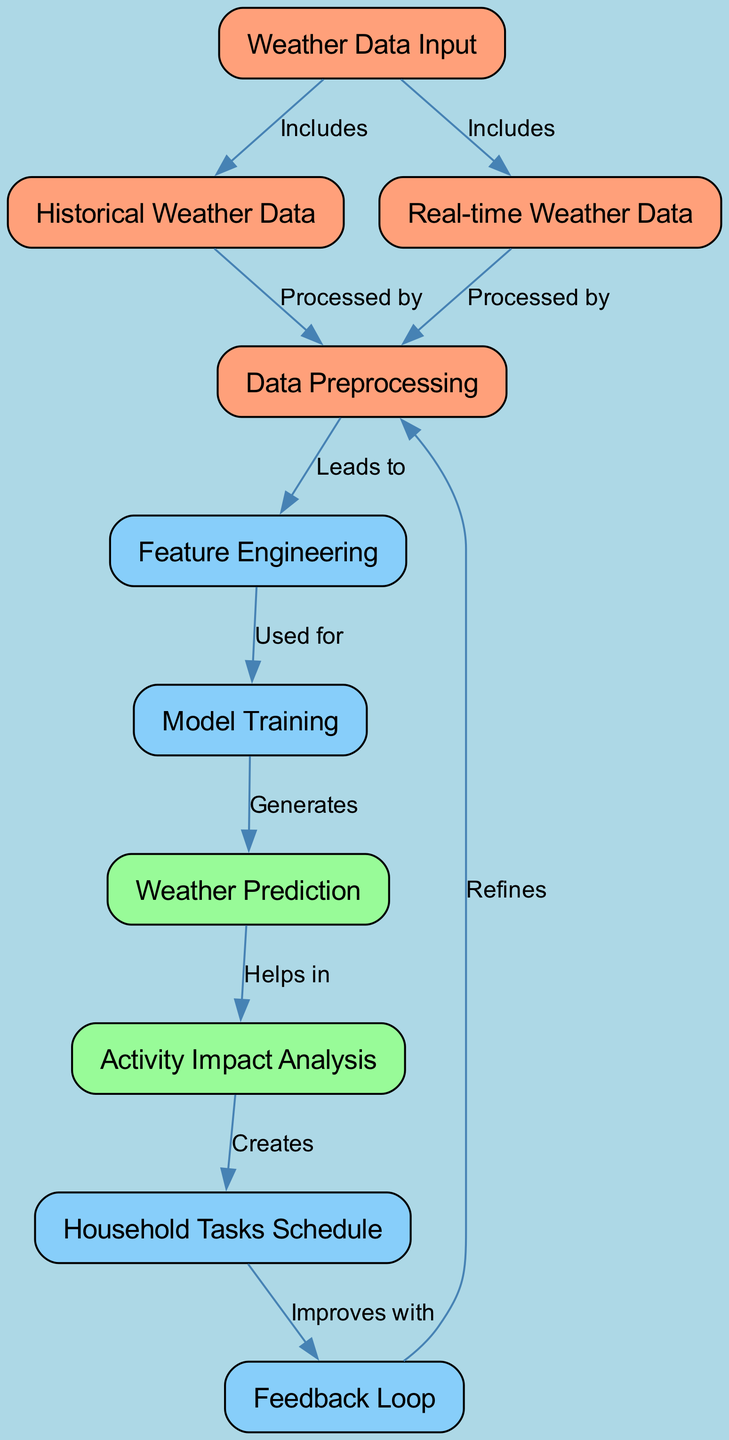What are the two types of weather data inputs? The diagram lists two types of weather data inputs: historical weather data and real-time weather data.
Answer: historical weather data, real-time weather data Which node comes after data preprocessing? The next node after data preprocessing is feature engineering, as shown in the diagram.
Answer: feature engineering How many nodes are present in the diagram? Counting all the nodes in the diagram reveals there are ten nodes total.
Answer: ten What is the purpose of the feedback loop in the diagram? The feedback loop refines the data preprocessing, indicating it helps improve the model based on past performance.
Answer: refines Which two nodes are directly connected to household tasks schedule? The household tasks schedule is directly connected to the activity impact analysis and the feedback loop, indicating relationships with both nodes.
Answer: activity impact analysis, feedback loop What is generated from model training? From model training, the output generated is weather prediction, as indicated by the diagram.
Answer: weather prediction Why is feedback loop important in this diagram? The feedback loop is crucial because it helps refine the data preprocessing, which can lead to better predictions in future analyses.
Answer: improves Which node assists in activity impact analysis? The node that assists in activity impact analysis is weather prediction, showing its importance in determining the effects of weather on planning.
Answer: weather prediction What leads to feature engineering? Data preprocessing leads to feature engineering, signifying that it's a necessary step before actually engineering features for model training.
Answer: leads to 